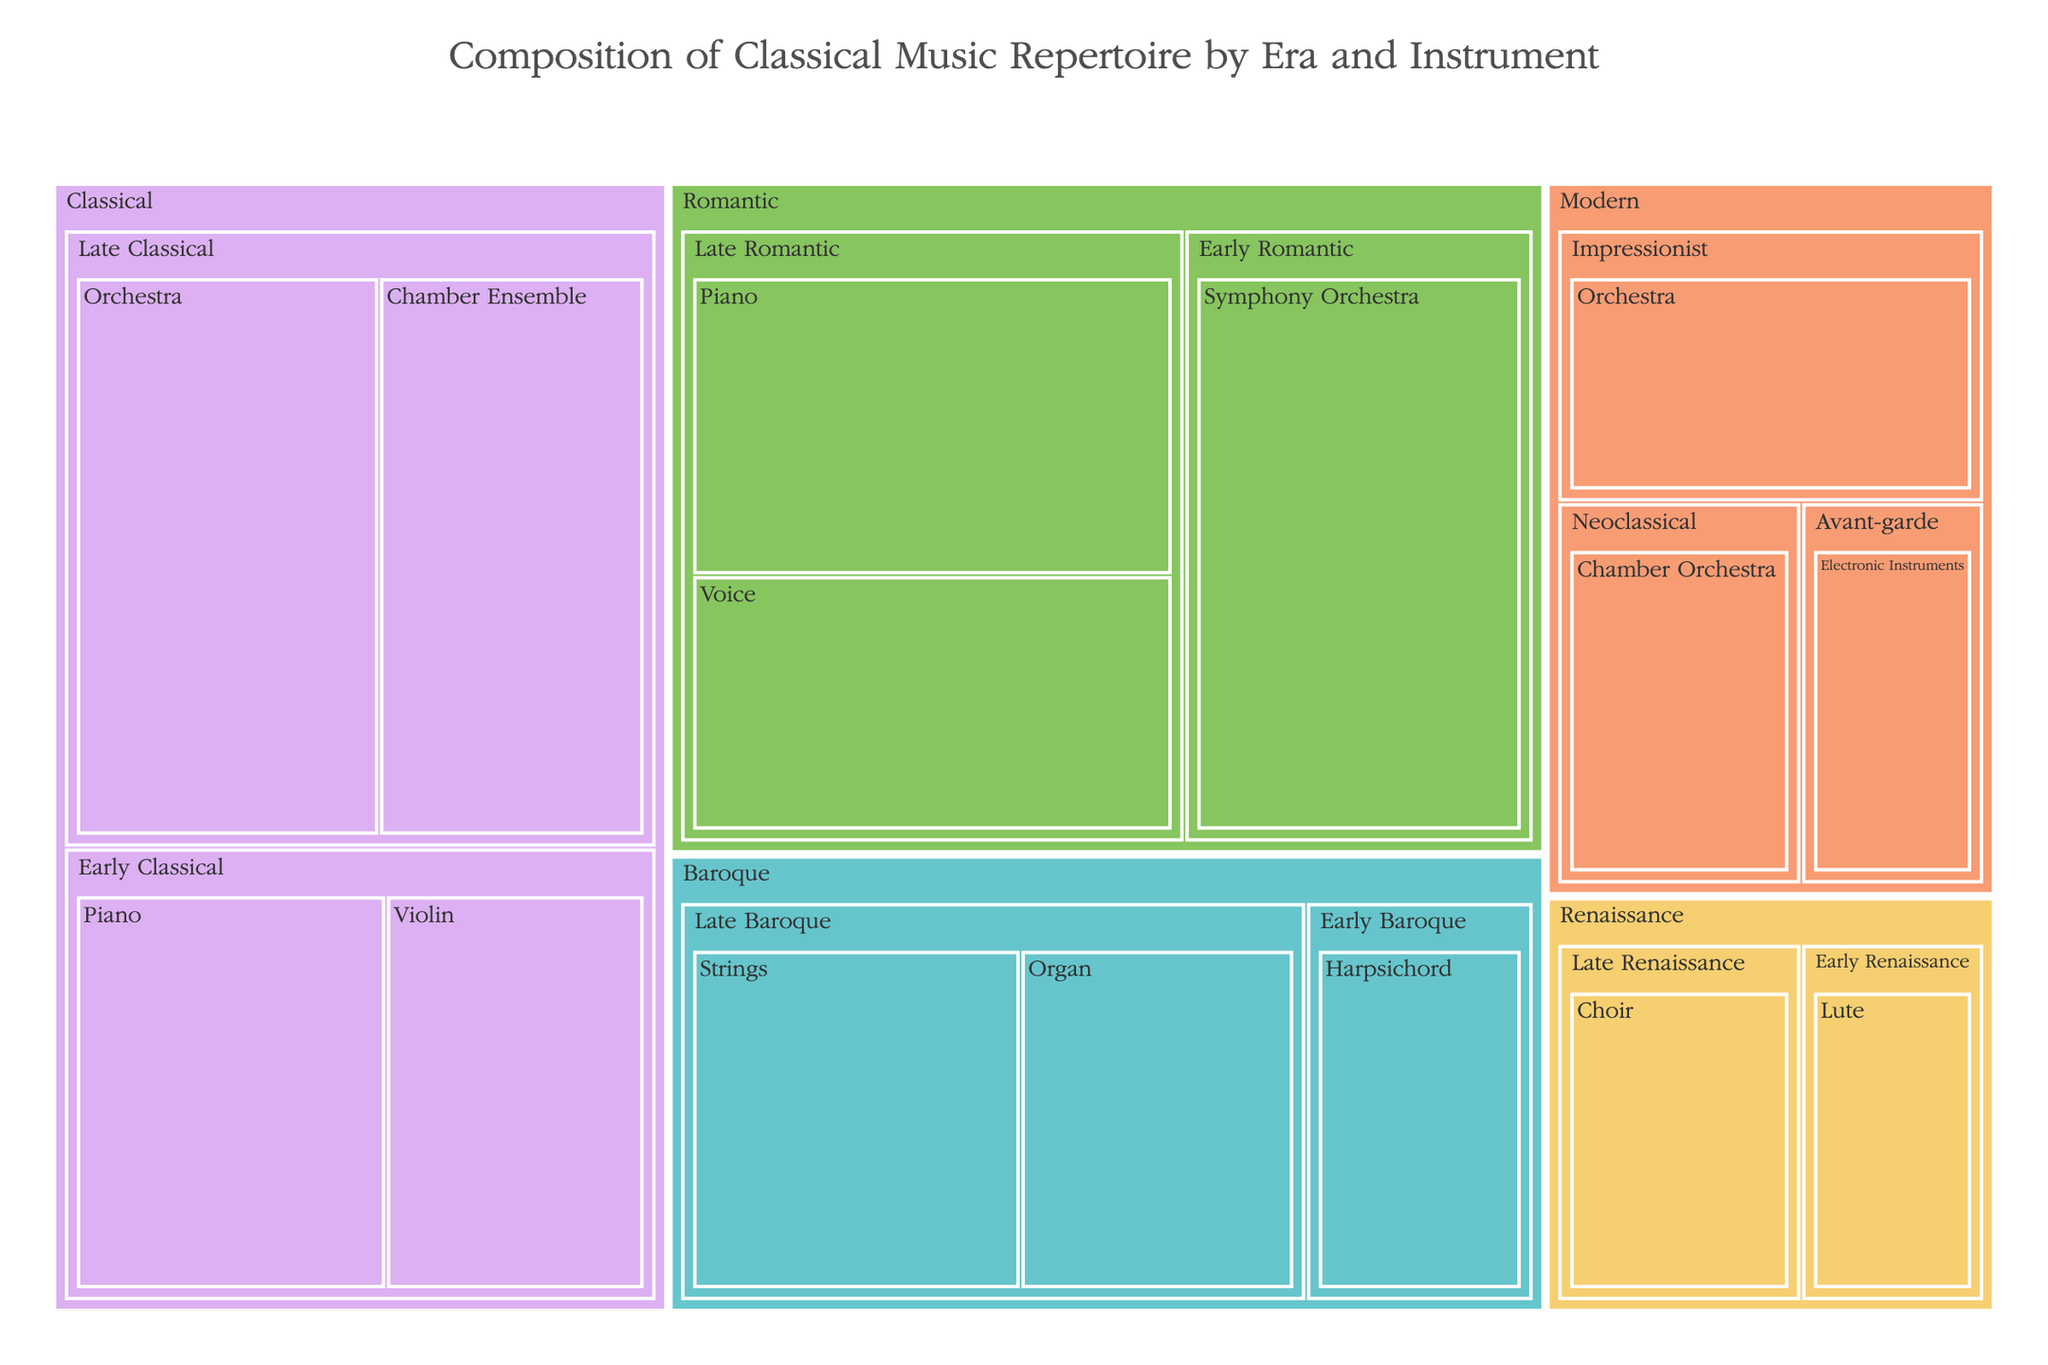what is the title of the treemap? The title is located at the top center of the treemap, it summarizes the data represented in the plot.
Answer: Composition of Classical Music Repertoire by Era and Instrument Which era has the highest representation according to the treemap? Examining the size of the areas in the treemap, the Classical era shows the largest area compared to the other eras.
Answer: Classical Which instrument is most represented in the Late Romantic period? Referencing the Late Romantic section of the treemap, the Piano holds the largest section in this period.
Answer: Piano Compare the representation of Piano between Early Classical and Late Romantic periods. In the Early Classical period, the Piano has a value of 30. In the Late Romantic period, it has a value of 35. Therefore, it is greater in the Late Romantic period.
Answer: Late Romantic How much combined value is represented by the Orchestra in the dataset? Adding the values related to Orchestra which are found in Late Classical (40), Early Romantic (45), and Impressionist (25). Summing them gives 40 + 45 + 25 = 110.
Answer: 110 Which period has the fewest instruments represented and what are they? By looking at the treemap, the Avant-garde period in the Modern era has the fewest instruments represented, which is only Electronic Instruments.
Answer: Avant-garde, Electronic Instruments Calculate the average value for all instruments in the Early Classical period. The values for Early Classical period instruments are Piano (30) and Violin (25). The sum is 30 + 25 = 55. The average is 55 / 2 = 27.5.
Answer: 27.5 Which eras encompass instruments with values of 30 or more? Identifying the sections that have values of 30 or more, they are Classical, Baroque, Romantic, and Modern (Impressionist and Avant-garde).
Answer: Classical, Baroque, Romantic, Modern What instrument dominates the Early Baroque period? The larger section within the Early Baroque period is attributed to the Harpsichord.
Answer: Harpsichord What color scheme is used to differentiate the eras in the treemap? The eras are presented using the Pastel color scheme for differentiation as stated in the description.
Answer: Pastel 